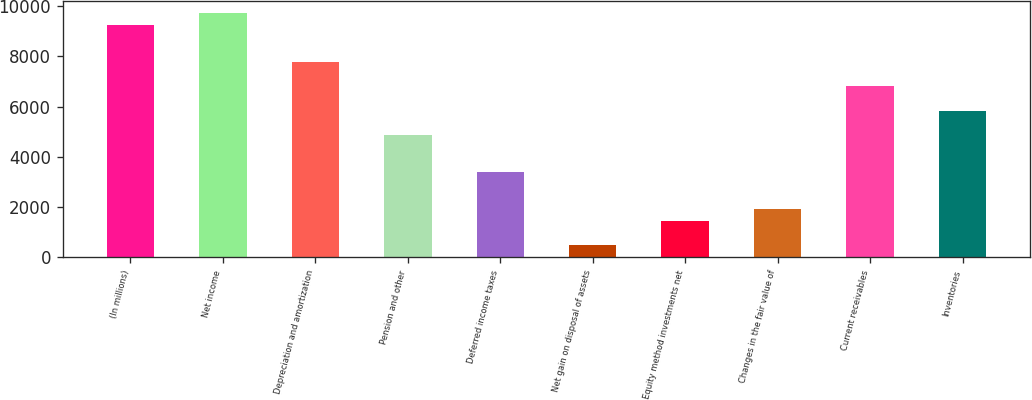Convert chart. <chart><loc_0><loc_0><loc_500><loc_500><bar_chart><fcel>(In millions)<fcel>Net income<fcel>Depreciation and amortization<fcel>Pension and other<fcel>Deferred income taxes<fcel>Net gain on disposal of assets<fcel>Equity method investments net<fcel>Changes in the fair value of<fcel>Current receivables<fcel>Inventories<nl><fcel>9230.4<fcel>9716<fcel>7773.6<fcel>4860<fcel>3403.2<fcel>489.6<fcel>1460.8<fcel>1946.4<fcel>6802.4<fcel>5831.2<nl></chart> 